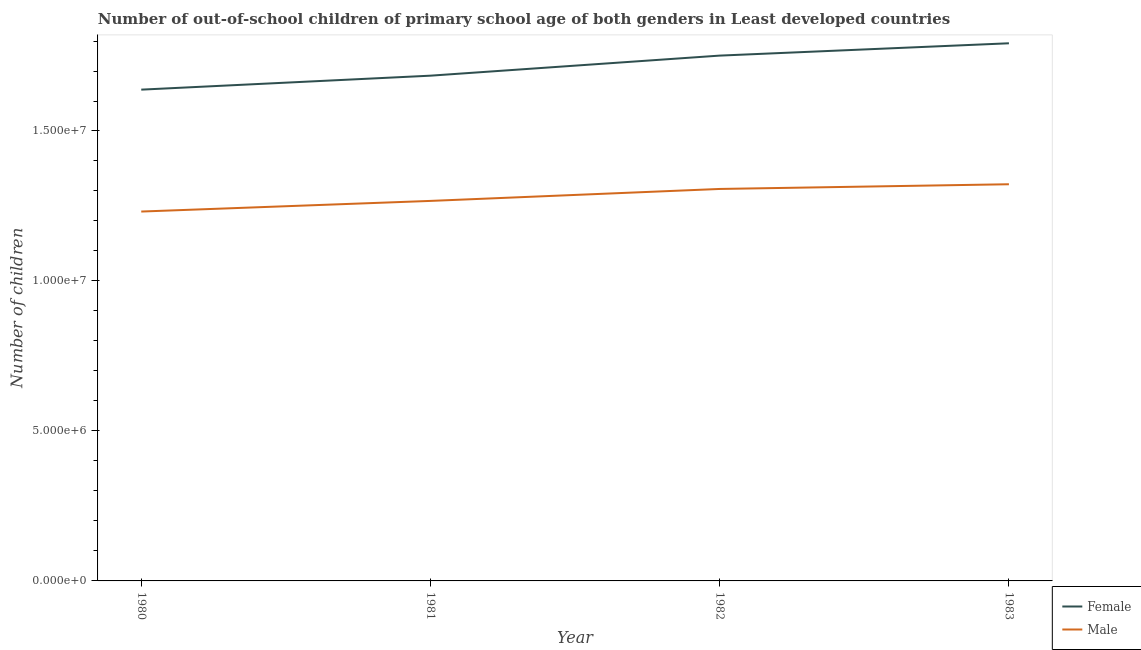How many different coloured lines are there?
Ensure brevity in your answer.  2. What is the number of female out-of-school students in 1982?
Make the answer very short. 1.75e+07. Across all years, what is the maximum number of male out-of-school students?
Your answer should be compact. 1.32e+07. Across all years, what is the minimum number of female out-of-school students?
Your answer should be compact. 1.64e+07. In which year was the number of female out-of-school students maximum?
Ensure brevity in your answer.  1983. What is the total number of male out-of-school students in the graph?
Provide a succinct answer. 5.13e+07. What is the difference between the number of male out-of-school students in 1981 and that in 1983?
Offer a terse response. -5.56e+05. What is the difference between the number of female out-of-school students in 1981 and the number of male out-of-school students in 1983?
Your answer should be compact. 3.62e+06. What is the average number of female out-of-school students per year?
Provide a short and direct response. 1.72e+07. In the year 1983, what is the difference between the number of female out-of-school students and number of male out-of-school students?
Keep it short and to the point. 4.70e+06. In how many years, is the number of female out-of-school students greater than 16000000?
Provide a short and direct response. 4. What is the ratio of the number of female out-of-school students in 1980 to that in 1983?
Offer a terse response. 0.91. Is the number of male out-of-school students in 1981 less than that in 1982?
Offer a terse response. Yes. What is the difference between the highest and the second highest number of male out-of-school students?
Keep it short and to the point. 1.57e+05. What is the difference between the highest and the lowest number of female out-of-school students?
Make the answer very short. 1.55e+06. Is the number of female out-of-school students strictly less than the number of male out-of-school students over the years?
Provide a succinct answer. No. How many lines are there?
Provide a short and direct response. 2. What is the difference between two consecutive major ticks on the Y-axis?
Offer a terse response. 5.00e+06. Are the values on the major ticks of Y-axis written in scientific E-notation?
Ensure brevity in your answer.  Yes. Does the graph contain grids?
Provide a succinct answer. No. How are the legend labels stacked?
Give a very brief answer. Vertical. What is the title of the graph?
Keep it short and to the point. Number of out-of-school children of primary school age of both genders in Least developed countries. Does "Age 65(male)" appear as one of the legend labels in the graph?
Offer a very short reply. No. What is the label or title of the Y-axis?
Provide a succinct answer. Number of children. What is the Number of children in Female in 1980?
Offer a very short reply. 1.64e+07. What is the Number of children of Male in 1980?
Your answer should be very brief. 1.23e+07. What is the Number of children in Female in 1981?
Offer a terse response. 1.68e+07. What is the Number of children in Male in 1981?
Provide a succinct answer. 1.27e+07. What is the Number of children in Female in 1982?
Ensure brevity in your answer.  1.75e+07. What is the Number of children of Male in 1982?
Offer a terse response. 1.31e+07. What is the Number of children in Female in 1983?
Provide a succinct answer. 1.79e+07. What is the Number of children of Male in 1983?
Offer a very short reply. 1.32e+07. Across all years, what is the maximum Number of children in Female?
Offer a terse response. 1.79e+07. Across all years, what is the maximum Number of children of Male?
Make the answer very short. 1.32e+07. Across all years, what is the minimum Number of children in Female?
Ensure brevity in your answer.  1.64e+07. Across all years, what is the minimum Number of children of Male?
Ensure brevity in your answer.  1.23e+07. What is the total Number of children in Female in the graph?
Offer a terse response. 6.87e+07. What is the total Number of children of Male in the graph?
Offer a terse response. 5.13e+07. What is the difference between the Number of children in Female in 1980 and that in 1981?
Your response must be concise. -4.66e+05. What is the difference between the Number of children of Male in 1980 and that in 1981?
Give a very brief answer. -3.54e+05. What is the difference between the Number of children in Female in 1980 and that in 1982?
Give a very brief answer. -1.13e+06. What is the difference between the Number of children of Male in 1980 and that in 1982?
Ensure brevity in your answer.  -7.53e+05. What is the difference between the Number of children in Female in 1980 and that in 1983?
Keep it short and to the point. -1.55e+06. What is the difference between the Number of children of Male in 1980 and that in 1983?
Offer a very short reply. -9.10e+05. What is the difference between the Number of children in Female in 1981 and that in 1982?
Your response must be concise. -6.69e+05. What is the difference between the Number of children of Male in 1981 and that in 1982?
Your response must be concise. -3.99e+05. What is the difference between the Number of children in Female in 1981 and that in 1983?
Offer a very short reply. -1.08e+06. What is the difference between the Number of children in Male in 1981 and that in 1983?
Provide a short and direct response. -5.56e+05. What is the difference between the Number of children in Female in 1982 and that in 1983?
Keep it short and to the point. -4.11e+05. What is the difference between the Number of children in Male in 1982 and that in 1983?
Offer a very short reply. -1.57e+05. What is the difference between the Number of children in Female in 1980 and the Number of children in Male in 1981?
Ensure brevity in your answer.  3.71e+06. What is the difference between the Number of children in Female in 1980 and the Number of children in Male in 1982?
Your response must be concise. 3.31e+06. What is the difference between the Number of children in Female in 1980 and the Number of children in Male in 1983?
Provide a short and direct response. 3.15e+06. What is the difference between the Number of children in Female in 1981 and the Number of children in Male in 1982?
Keep it short and to the point. 3.78e+06. What is the difference between the Number of children in Female in 1981 and the Number of children in Male in 1983?
Offer a very short reply. 3.62e+06. What is the difference between the Number of children in Female in 1982 and the Number of children in Male in 1983?
Provide a succinct answer. 4.29e+06. What is the average Number of children of Female per year?
Ensure brevity in your answer.  1.72e+07. What is the average Number of children of Male per year?
Offer a terse response. 1.28e+07. In the year 1980, what is the difference between the Number of children in Female and Number of children in Male?
Offer a very short reply. 4.06e+06. In the year 1981, what is the difference between the Number of children in Female and Number of children in Male?
Give a very brief answer. 4.18e+06. In the year 1982, what is the difference between the Number of children of Female and Number of children of Male?
Keep it short and to the point. 4.45e+06. In the year 1983, what is the difference between the Number of children of Female and Number of children of Male?
Your response must be concise. 4.70e+06. What is the ratio of the Number of children of Female in 1980 to that in 1981?
Your answer should be very brief. 0.97. What is the ratio of the Number of children in Female in 1980 to that in 1982?
Offer a terse response. 0.94. What is the ratio of the Number of children in Male in 1980 to that in 1982?
Offer a very short reply. 0.94. What is the ratio of the Number of children of Female in 1980 to that in 1983?
Make the answer very short. 0.91. What is the ratio of the Number of children in Male in 1980 to that in 1983?
Provide a short and direct response. 0.93. What is the ratio of the Number of children of Female in 1981 to that in 1982?
Keep it short and to the point. 0.96. What is the ratio of the Number of children of Male in 1981 to that in 1982?
Give a very brief answer. 0.97. What is the ratio of the Number of children of Female in 1981 to that in 1983?
Provide a succinct answer. 0.94. What is the ratio of the Number of children of Male in 1981 to that in 1983?
Give a very brief answer. 0.96. What is the ratio of the Number of children of Female in 1982 to that in 1983?
Keep it short and to the point. 0.98. What is the difference between the highest and the second highest Number of children in Female?
Provide a short and direct response. 4.11e+05. What is the difference between the highest and the second highest Number of children in Male?
Ensure brevity in your answer.  1.57e+05. What is the difference between the highest and the lowest Number of children in Female?
Offer a very short reply. 1.55e+06. What is the difference between the highest and the lowest Number of children in Male?
Your answer should be very brief. 9.10e+05. 